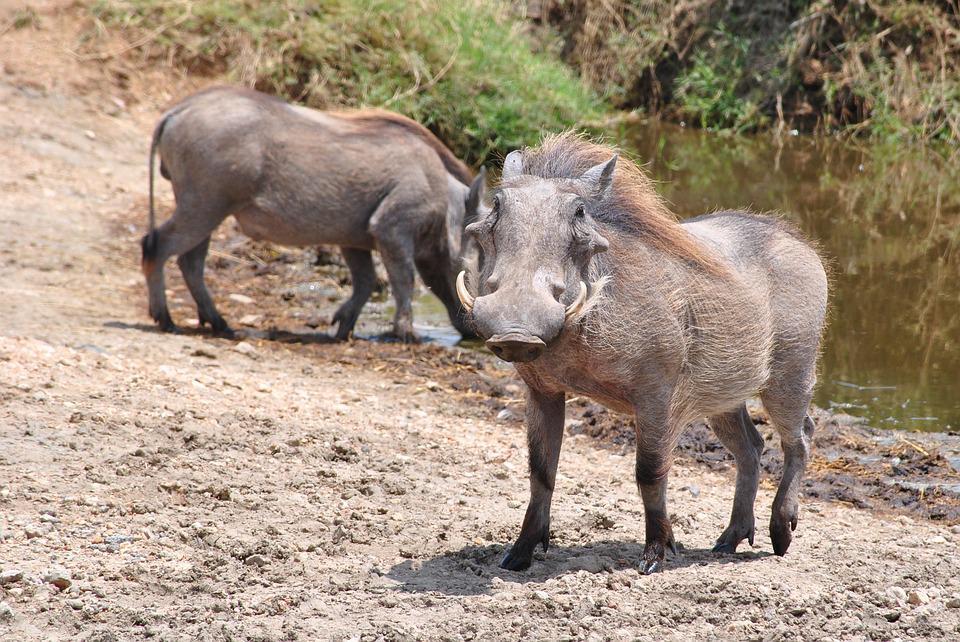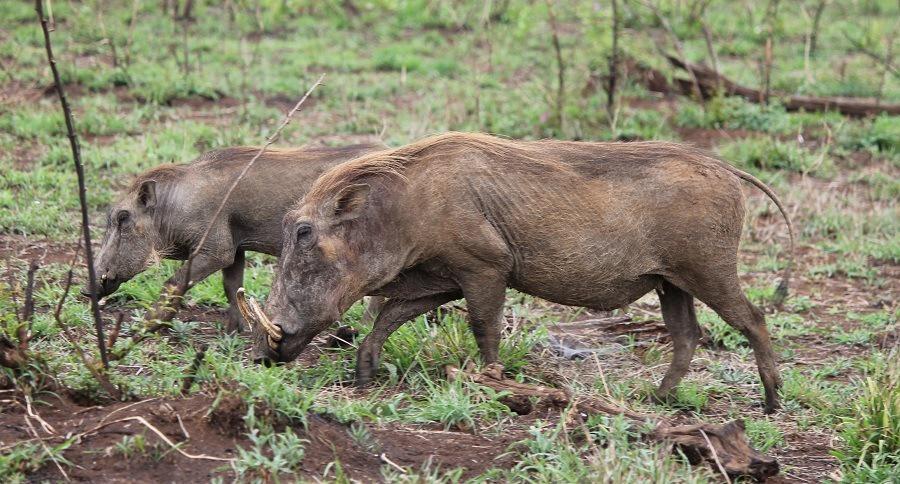The first image is the image on the left, the second image is the image on the right. Considering the images on both sides, is "The only animals shown are exactly two warthogs, in total." valid? Answer yes or no. No. 